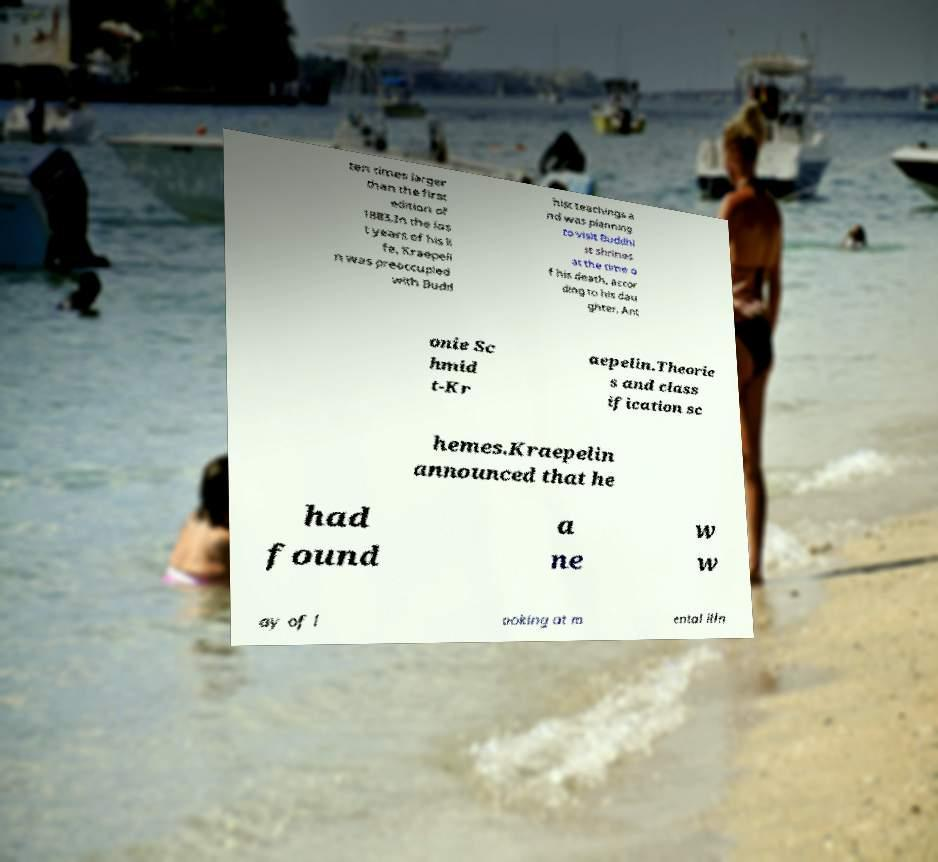There's text embedded in this image that I need extracted. Can you transcribe it verbatim? ten times larger than the first edition of 1883.In the las t years of his li fe, Kraepeli n was preoccupied with Budd hist teachings a nd was planning to visit Buddhi st shrines at the time o f his death, accor ding to his dau ghter, Ant onie Sc hmid t-Kr aepelin.Theorie s and class ification sc hemes.Kraepelin announced that he had found a ne w w ay of l ooking at m ental illn 